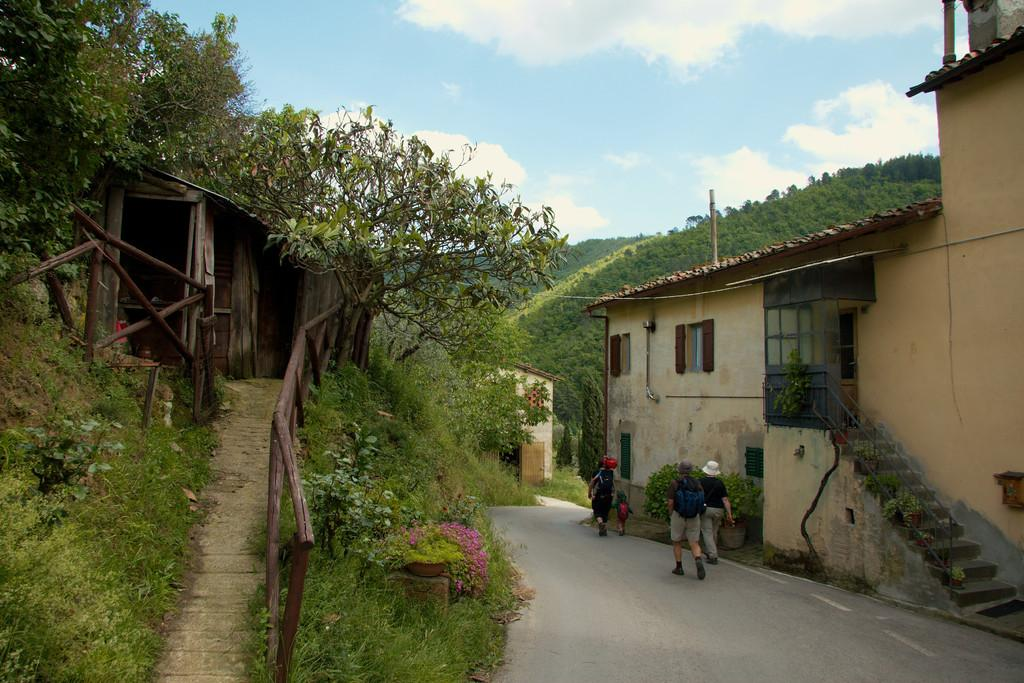What are the people in the image doing? The people in the image are walking on the road. What type of vegetation can be seen in the image? Grass, plants, and trees are present in the image. What kind of structure is visible in the image? There is a wooden house in the image. What architectural feature is present in the image? A fence is visible in the image. Are there any stairs in the image? Yes, there are stairs in the image. What can be seen in the background of the image? The sky is visible in the background of the image, with clouds present. Can you tell me the direction the hole is facing in the image? There is no hole present in the image. What role does the actor play in the image? There is no actor present in the image. 